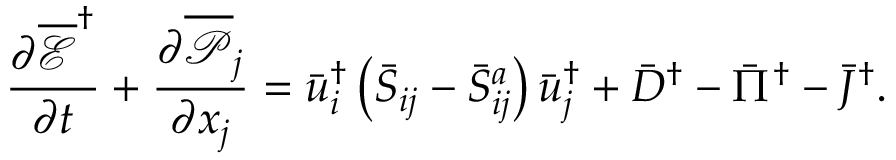<formula> <loc_0><loc_0><loc_500><loc_500>\frac { { \partial { { \overline { \mathcal { E } } } ^ { \dag } } } } { \partial t } + \frac { { \partial { { \overline { \mathcal { P } } } _ { j } } } } { { \partial { x _ { j } } } } = \bar { u } _ { i } ^ { \dag } \left ( { { { \bar { S } } _ { i j } } - \bar { S } _ { i j } ^ { a } } \right ) \bar { u } _ { j } ^ { \dag } + { { \bar { D } } ^ { \dag } } - { { \bar { \Pi } } ^ { \dag } } - { { \bar { J } } ^ { \dag } } .</formula> 